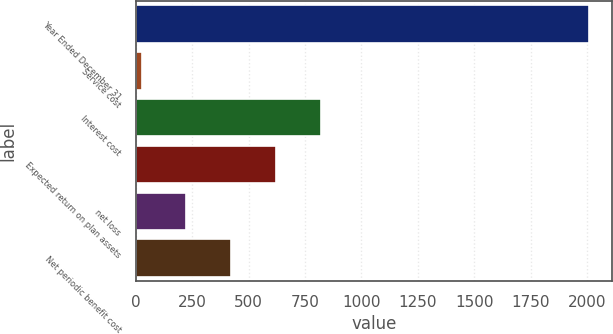Convert chart to OTSL. <chart><loc_0><loc_0><loc_500><loc_500><bar_chart><fcel>Year Ended December 31<fcel>Service cost<fcel>Interest cost<fcel>Expected return on plan assets<fcel>net loss<fcel>Net periodic benefit cost<nl><fcel>2009<fcel>26<fcel>819.2<fcel>620.9<fcel>224.3<fcel>422.6<nl></chart> 